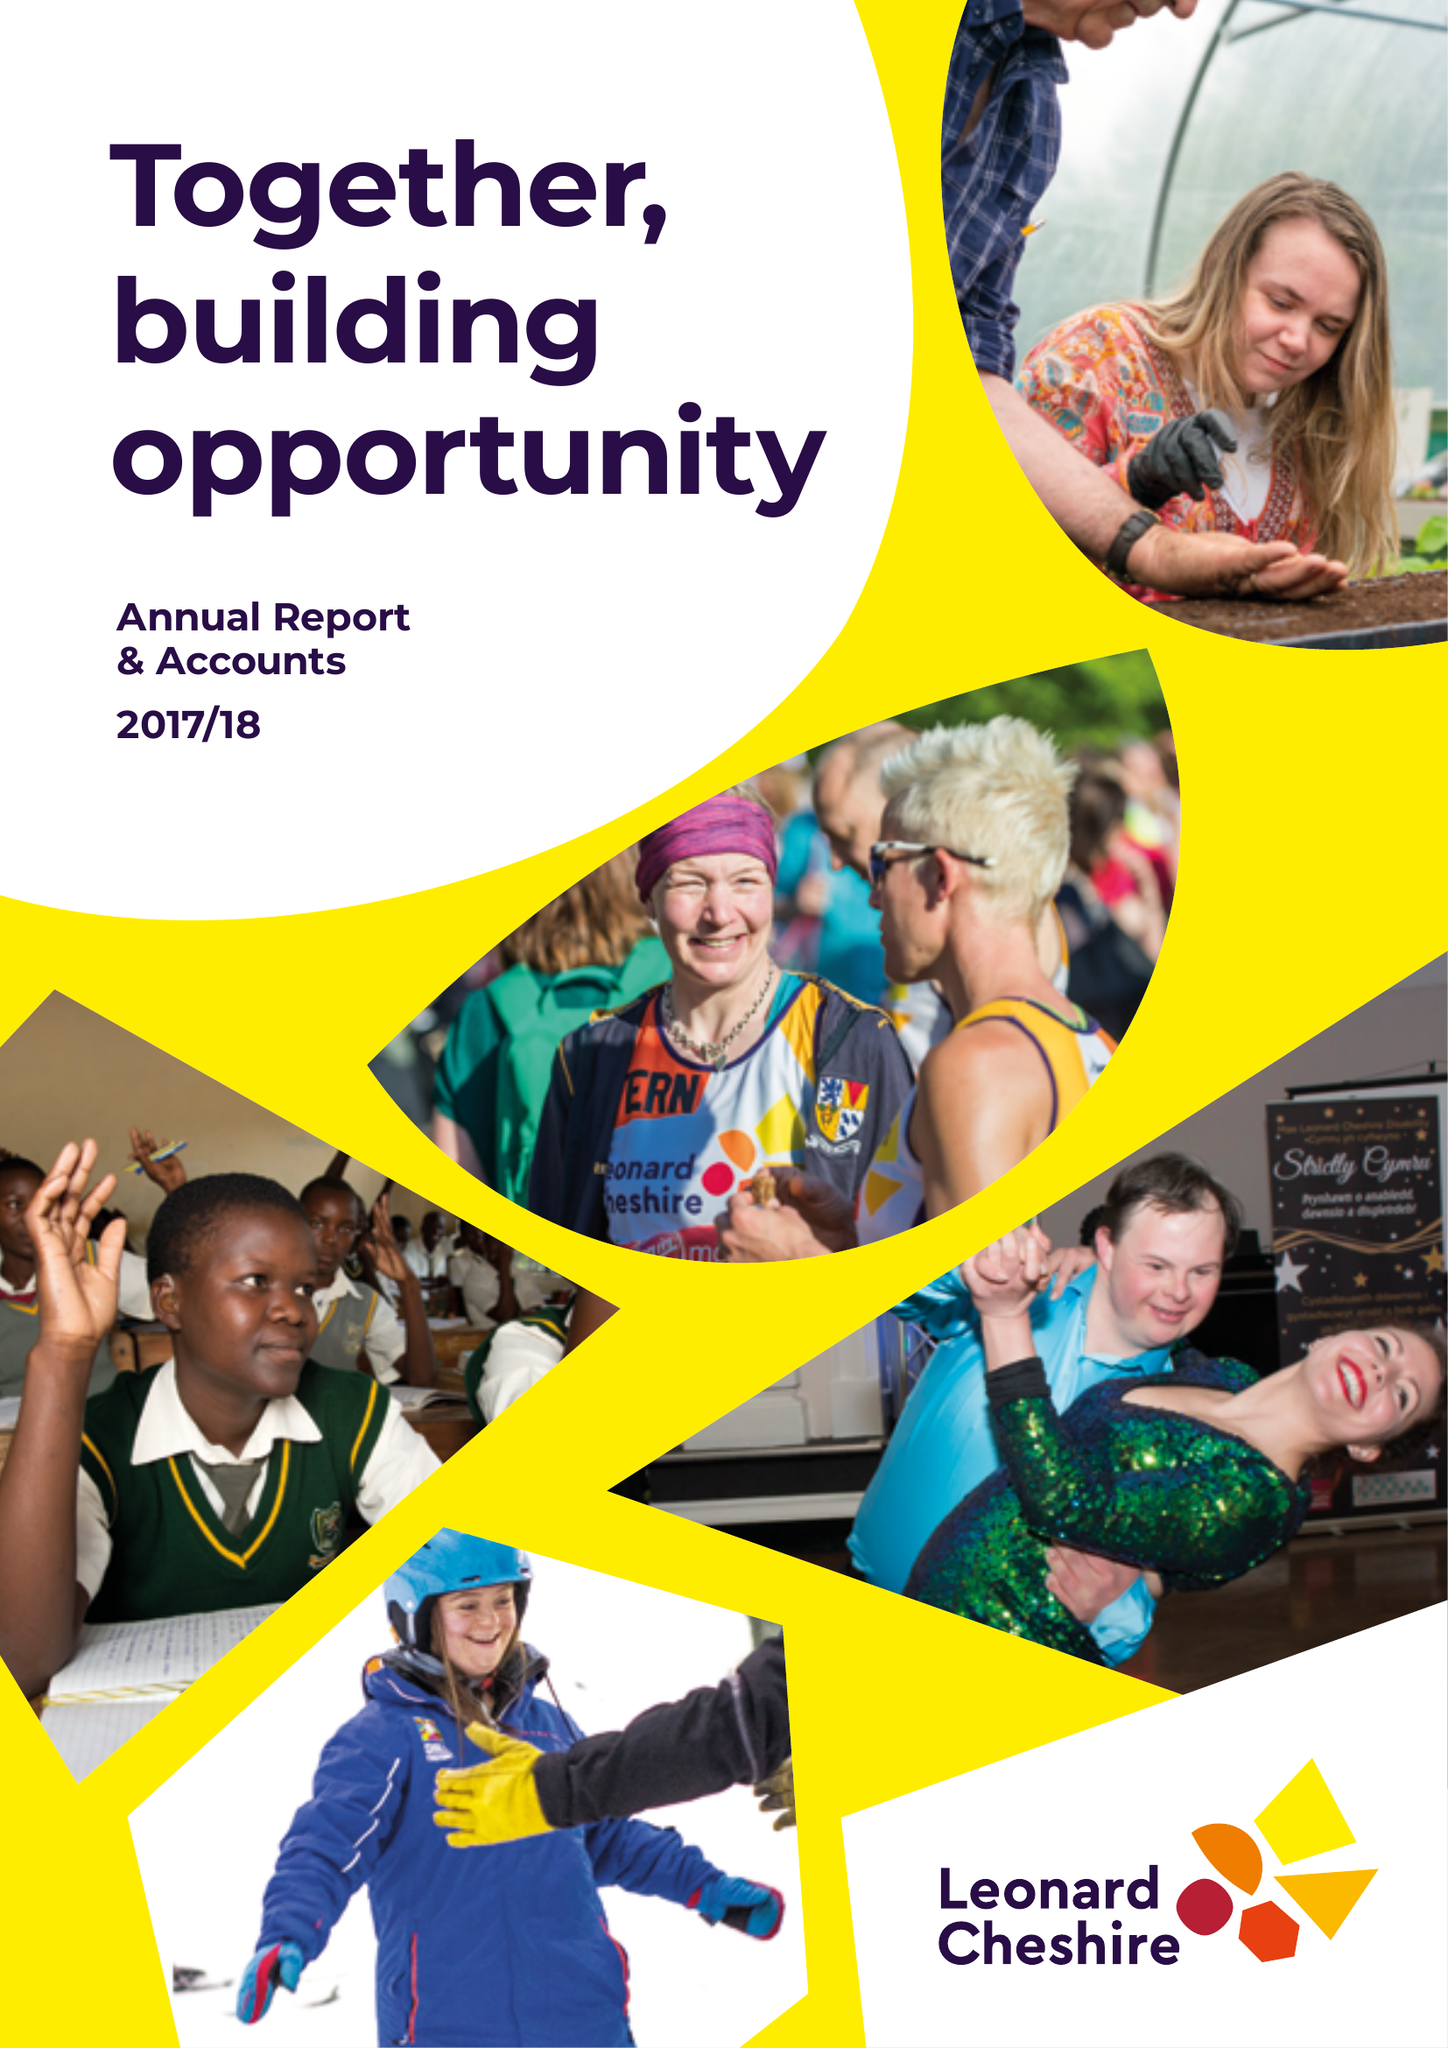What is the value for the report_date?
Answer the question using a single word or phrase. 2018-03-31 